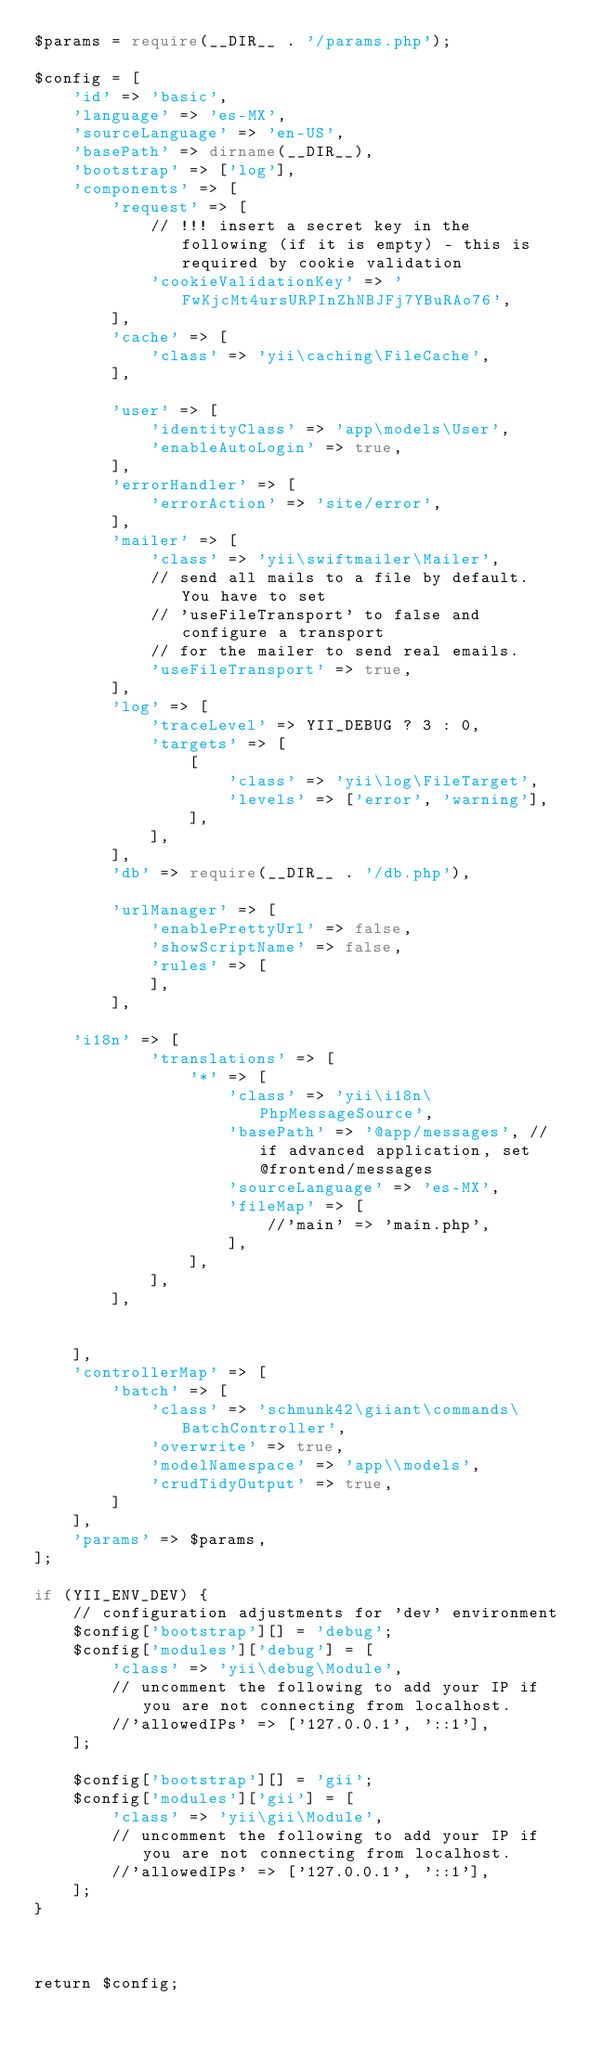<code> <loc_0><loc_0><loc_500><loc_500><_PHP_>$params = require(__DIR__ . '/params.php');

$config = [
    'id' => 'basic',
    'language' => 'es-MX',
    'sourceLanguage' => 'en-US',
    'basePath' => dirname(__DIR__),
    'bootstrap' => ['log'],
    'components' => [
        'request' => [
            // !!! insert a secret key in the following (if it is empty) - this is required by cookie validation
            'cookieValidationKey' => 'FwKjcMt4ursURPInZhNBJFj7YBuRAo76',
        ],
        'cache' => [
            'class' => 'yii\caching\FileCache',
        ],

        'user' => [
            'identityClass' => 'app\models\User',
            'enableAutoLogin' => true,
        ],
        'errorHandler' => [
            'errorAction' => 'site/error',
        ],
        'mailer' => [
            'class' => 'yii\swiftmailer\Mailer',
            // send all mails to a file by default. You have to set
            // 'useFileTransport' to false and configure a transport
            // for the mailer to send real emails.
            'useFileTransport' => true,
        ],
        'log' => [
            'traceLevel' => YII_DEBUG ? 3 : 0,
            'targets' => [
                [
                    'class' => 'yii\log\FileTarget',
                    'levels' => ['error', 'warning'],
                ],
            ],
        ],
        'db' => require(__DIR__ . '/db.php'),

        'urlManager' => [
            'enablePrettyUrl' => false,
            'showScriptName' => false,
            'rules' => [
            ],
        ],

    'i18n' => [
            'translations' => [
                '*' => [
                    'class' => 'yii\i18n\PhpMessageSource',
                    'basePath' => '@app/messages', // if advanced application, set @frontend/messages
                    'sourceLanguage' => 'es-MX',
                    'fileMap' => [
                        //'main' => 'main.php',
                    ],
                ],
            ],
        ],
            

    ],
    'controllerMap' => [
        'batch' => [
            'class' => 'schmunk42\giiant\commands\BatchController',
            'overwrite' => true,
            'modelNamespace' => 'app\\models',
            'crudTidyOutput' => true,
        ]
    ],
    'params' => $params,
];

if (YII_ENV_DEV) {
    // configuration adjustments for 'dev' environment
    $config['bootstrap'][] = 'debug';
    $config['modules']['debug'] = [
        'class' => 'yii\debug\Module',
        // uncomment the following to add your IP if you are not connecting from localhost.
        //'allowedIPs' => ['127.0.0.1', '::1'],
    ];

    $config['bootstrap'][] = 'gii';
    $config['modules']['gii'] = [
        'class' => 'yii\gii\Module',
        // uncomment the following to add your IP if you are not connecting from localhost.
        //'allowedIPs' => ['127.0.0.1', '::1'],
    ];
}



return $config;
</code> 